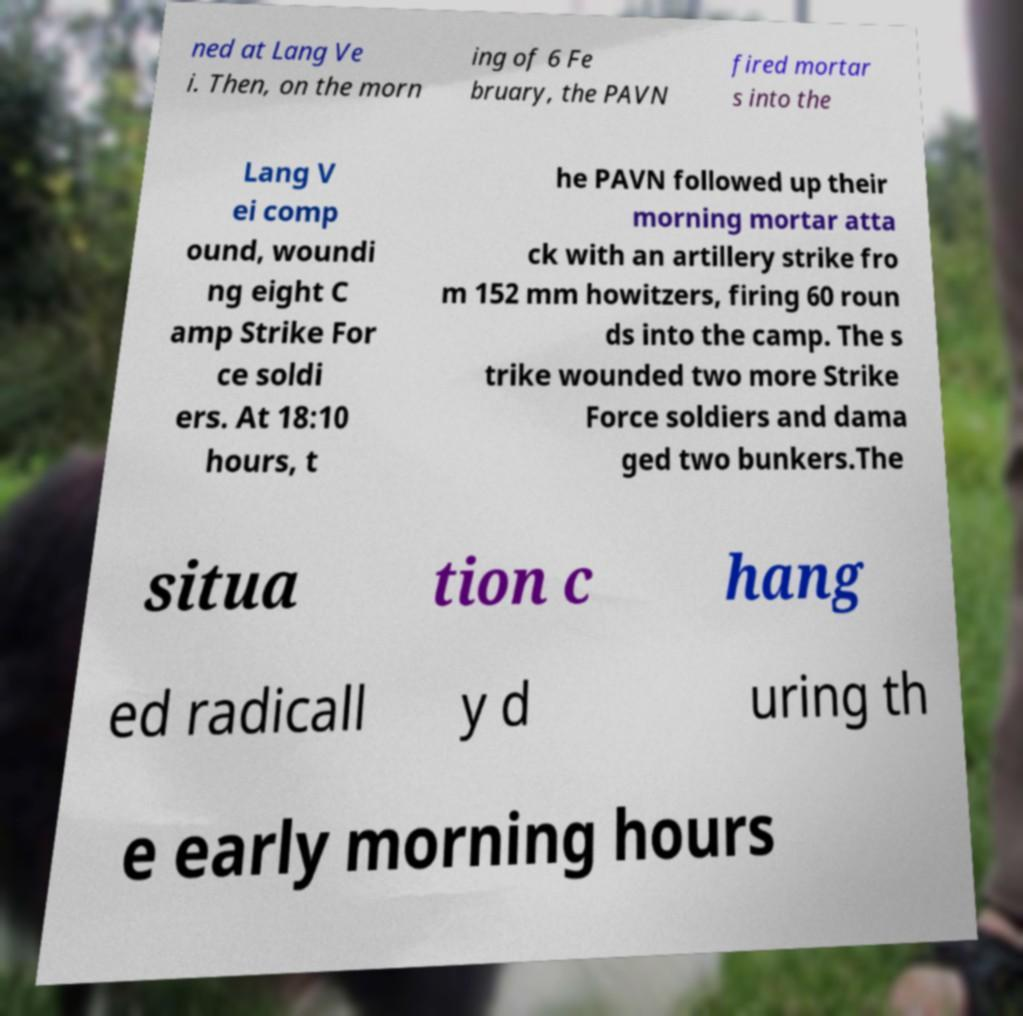Please read and relay the text visible in this image. What does it say? ned at Lang Ve i. Then, on the morn ing of 6 Fe bruary, the PAVN fired mortar s into the Lang V ei comp ound, woundi ng eight C amp Strike For ce soldi ers. At 18:10 hours, t he PAVN followed up their morning mortar atta ck with an artillery strike fro m 152 mm howitzers, firing 60 roun ds into the camp. The s trike wounded two more Strike Force soldiers and dama ged two bunkers.The situa tion c hang ed radicall y d uring th e early morning hours 